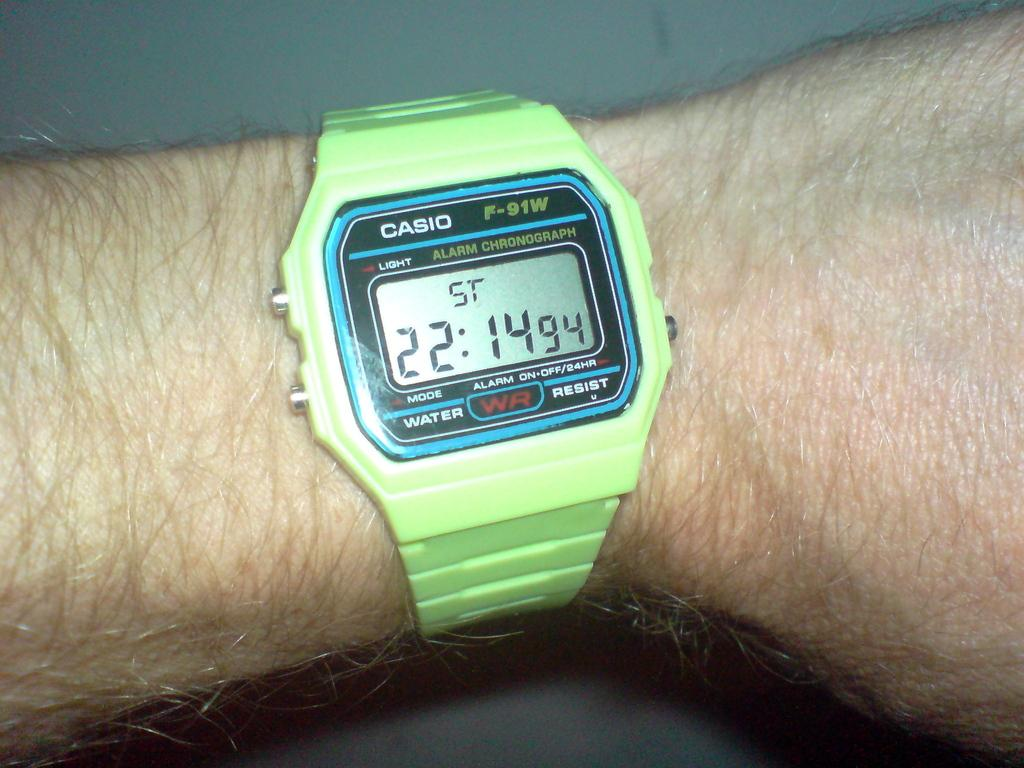<image>
Describe the image concisely. a close up of a Casio green wrist watch on a hairy arm 